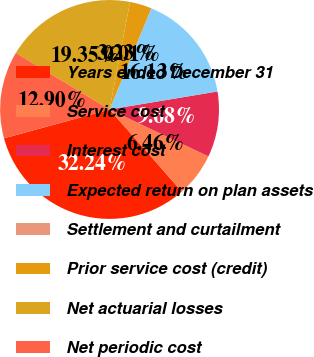Convert chart to OTSL. <chart><loc_0><loc_0><loc_500><loc_500><pie_chart><fcel>Years ended December 31<fcel>Service cost<fcel>Interest cost<fcel>Expected return on plan assets<fcel>Settlement and curtailment<fcel>Prior service cost (credit)<fcel>Net actuarial losses<fcel>Net periodic cost<nl><fcel>32.24%<fcel>6.46%<fcel>9.68%<fcel>16.13%<fcel>0.01%<fcel>3.23%<fcel>19.35%<fcel>12.9%<nl></chart> 